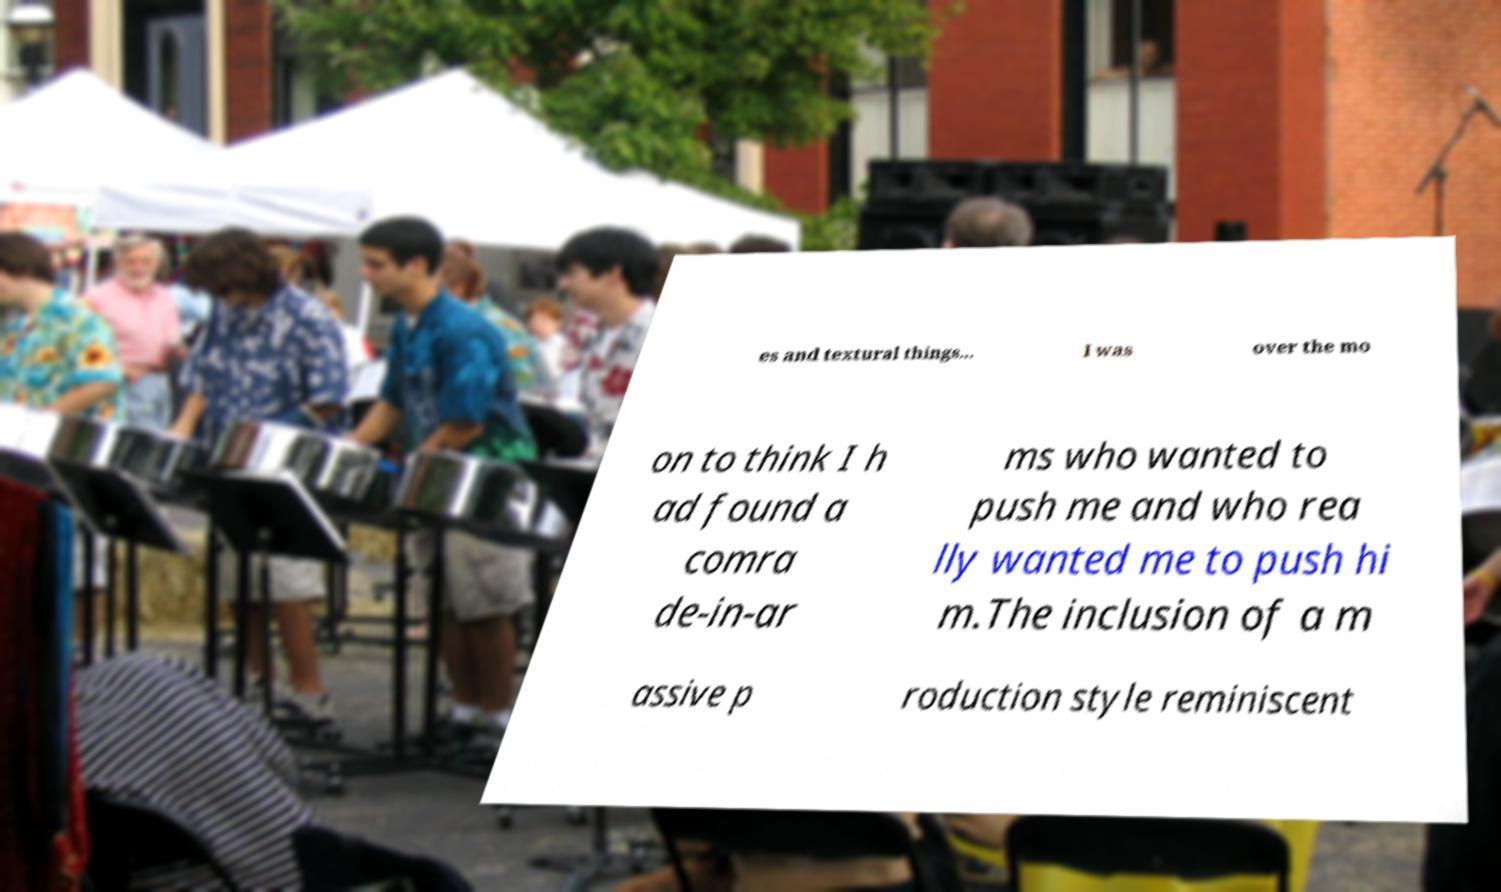Please read and relay the text visible in this image. What does it say? es and textural things... I was over the mo on to think I h ad found a comra de-in-ar ms who wanted to push me and who rea lly wanted me to push hi m.The inclusion of a m assive p roduction style reminiscent 